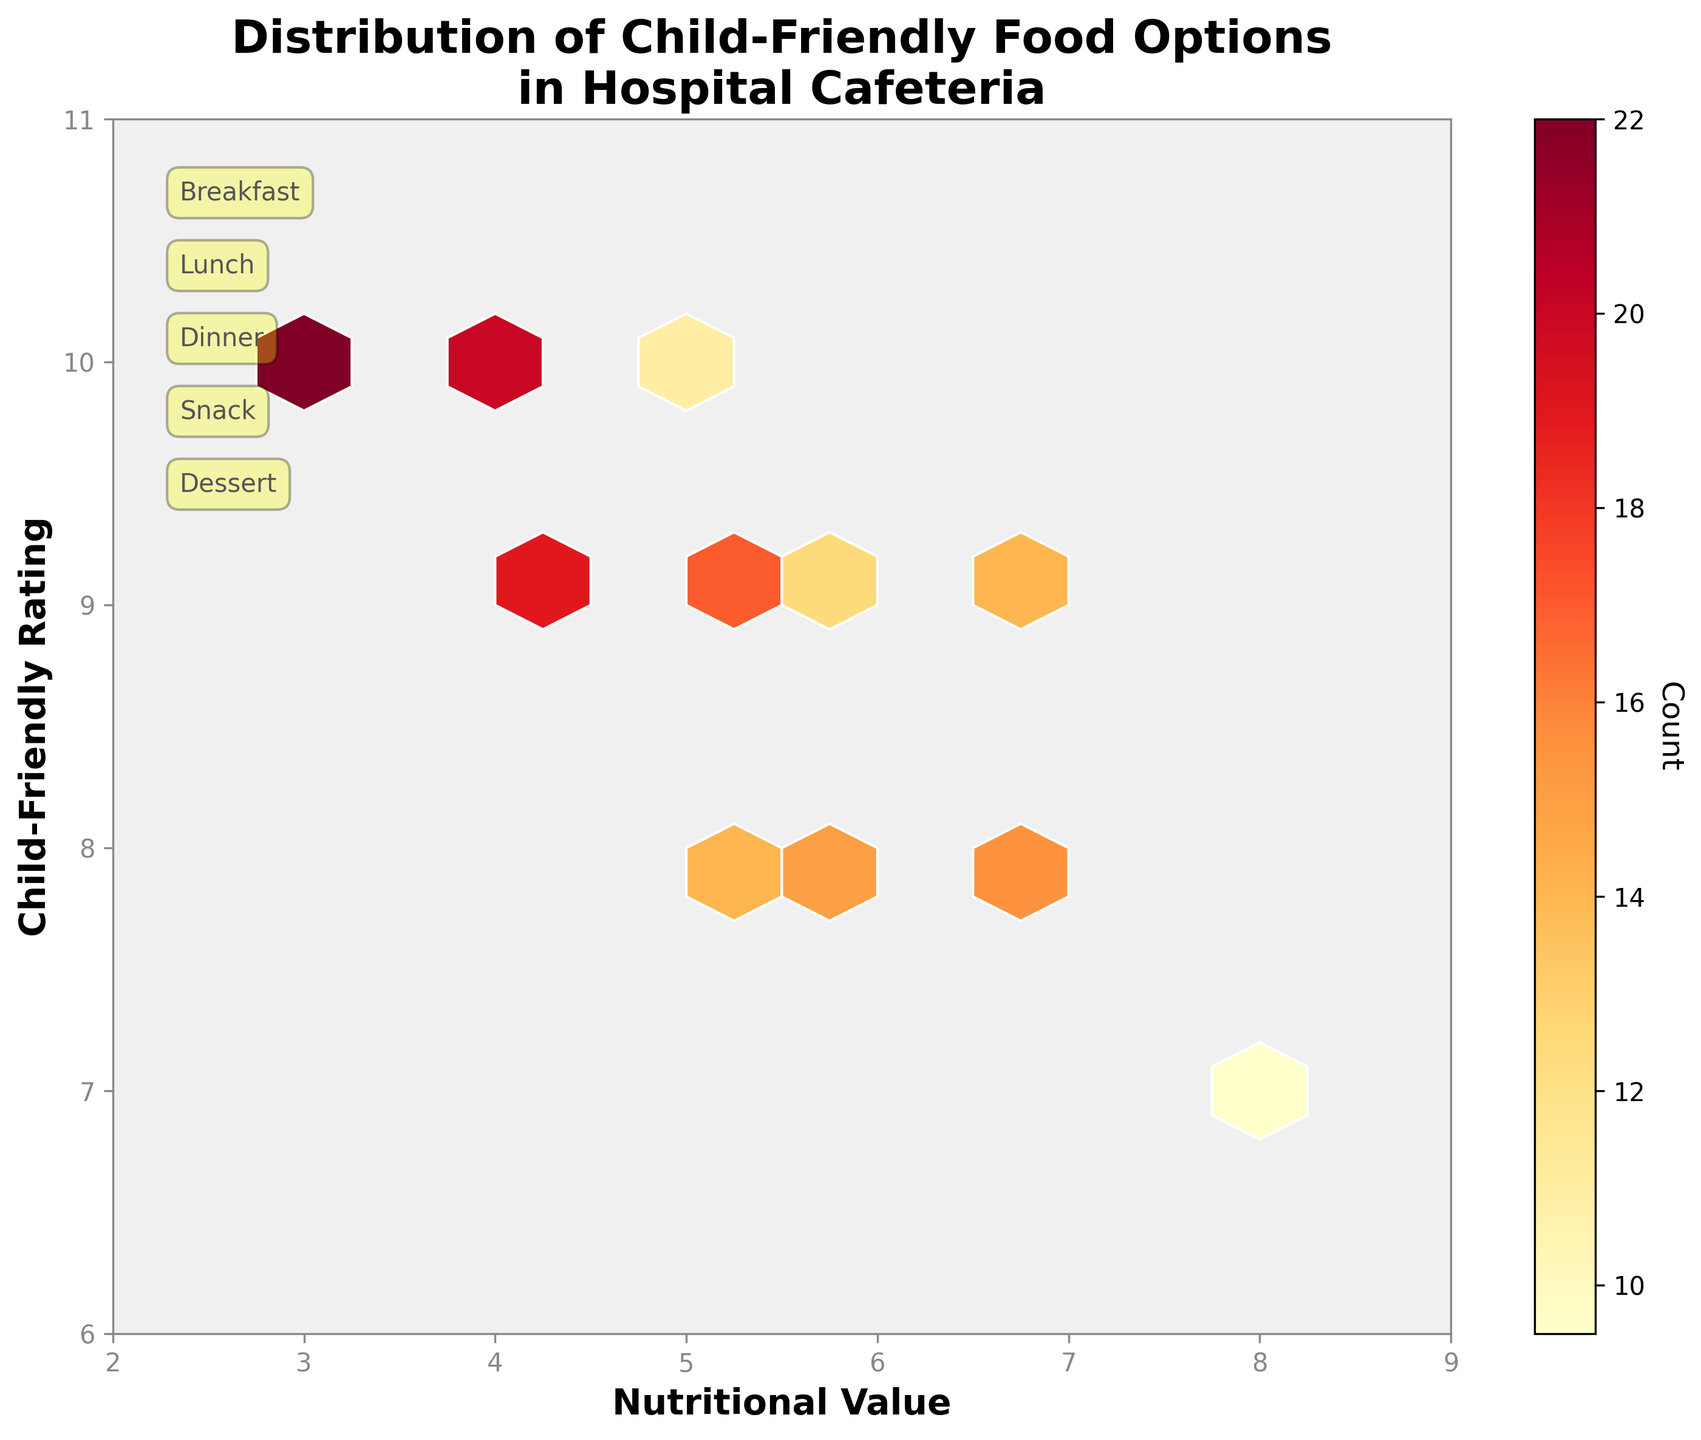What is the title of the figure? The title of the figure is written at the top in larger font, it describes what the plot is about.
Answer: Distribution of Child-Friendly Food Options in Hospital Cafeteria What does the x-axis represent? The x-axis label is found along the bottom of the plot, stating what it measures.
Answer: Nutritional Value What does the y-axis represent? The y-axis label is located along the left side of the plot, indicating the measured parameter.
Answer: Child-Friendly Rating What color scheme is used in the hexbin plot? The colors in the plot range from light yellow to dark red, showing different intensities of data points.
Answer: Yellow to Red (YlOrRd) How many different meal types are annotated on the plot? The meal types are annotated on the plot with small text boxes, typically found around the edges or in specific regions.
Answer: Five (Breakfast, Lunch, Dinner, Snack, Dessert) In which range does the x-axis (Nutritional Value) extend? The limits of the x-axis can be determined by looking at the scale along the bottom of the plot.
Answer: 2 to 9 What is the maximum count for any food options according to the colorbar? The colorbar on the right side of the plot shows the scale for count, indicating the highest count value.
Answer: 22 Compare the average Child-Friendly Rating for foods with Nutritional Values of 6 and 7. Which is higher? Identify the average child-friendly rating for both nutritional values by roughly visualizing the density of the hexbin cells, then compare.
Answer: 7 Which meal type seems to have the highest child-friendly rating? By observing the annotations and the color intensity in different regions, one can determine which areas have the highest child-friendly ratings and correlate with meal types.
Answer: Dessert Which combination of Nutritional Value and Child-Friendly Rating has the highest concentration of child-friendly food options? Look for the darkest red hexbin cell, which indicates the highest count of food options, then note the corresponding x and y values.
Answer: Nutritional Value 4, Child-Friendly Rating 10 